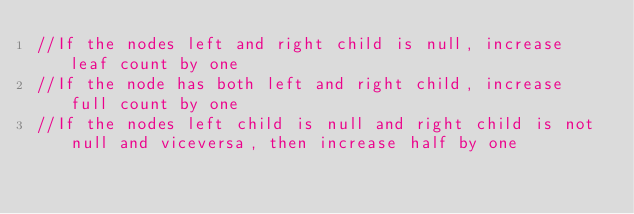<code> <loc_0><loc_0><loc_500><loc_500><_Java_>//If the nodes left and right child is null, increase leaf count by one
//If the node has both left and right child, increase full count by one
//If the nodes left child is null and right child is not null and viceversa, then increase half by one
</code> 